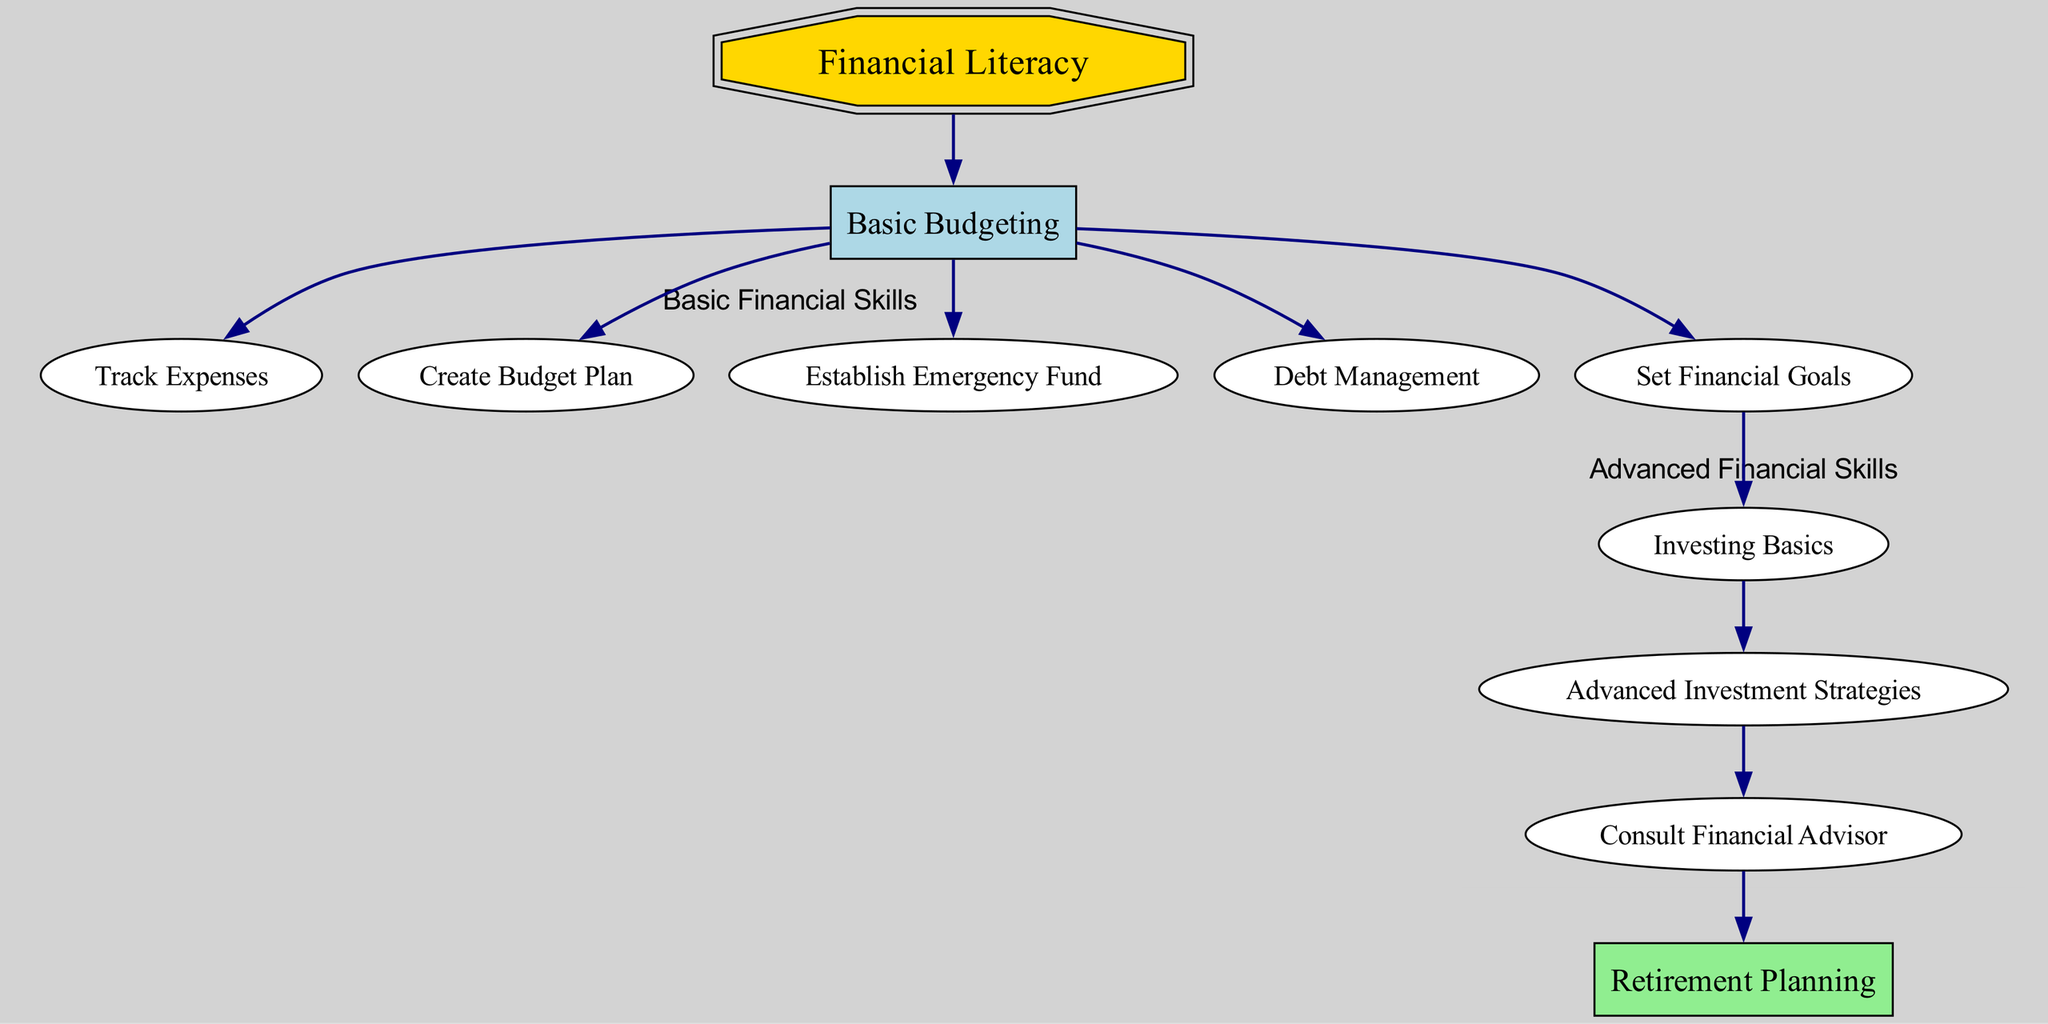What is the first step towards achieving financial literacy? The diagram shows that "Basic Budgeting" is the first step that leads to financial literacy. This can be seen as the primary node that connects to various budgeting actions.
Answer: Basic Budgeting How many nodes are there in total in the diagram? Counting all unique nodes listed in the diagram, we find there are 11 nodes, ranging from financial literacy to retirement planning.
Answer: 11 What relationship exists between "Basic Budgeting" and "Financial Goals"? The diagram indicates a direct connection where "Basic Budgeting" leads to "Financial Goals". Basic budgeting helps in establishing goals that guide further financial decisions.
Answer: Leads to What are the steps after setting financial goals? When looking at the flow, the next step after setting financial goals is "Investing Basics". This shows a progression from goal setting to approaches in investing.
Answer: Investing Basics Which node follows "Consult Financial Advisor"? According to the diagram, after consulting a financial advisor, the next action is "Retirement Planning". This indicates a process where professional advice leads towards planning for retirement.
Answer: Retirement Planning What color represents the node for financial literacy? The "Financial Literacy" node is colored gold as per its unique visual style indicated in the diagram.
Answer: Gold How many direct connections (edges) are there from "Basic Budgeting"? "Basic Budgeting" has 6 outgoing edges leading to "Track Expenses", "Create Budget Plan", "Establish Emergency Fund", "Debt Management", and "Financial Goals", indicating various paths stemming from this node.
Answer: 6 What are the three advanced financial skills listed in the diagram? The three advanced financial skills as per the diagram are "Investing Basics", "Investment Strategies", and "Consult Financial Advisor". These skills build on the foundation set by earlier steps.
Answer: Investing Basics, Investment Strategies, Consult Financial Advisor What node represents the last step in the financial literacy pathway? "Retirement Planning" is depicted as the final node in the pathway, signifying it as the culmination of effective financial literacy efforts leading to comprehensive life planning.
Answer: Retirement Planning 